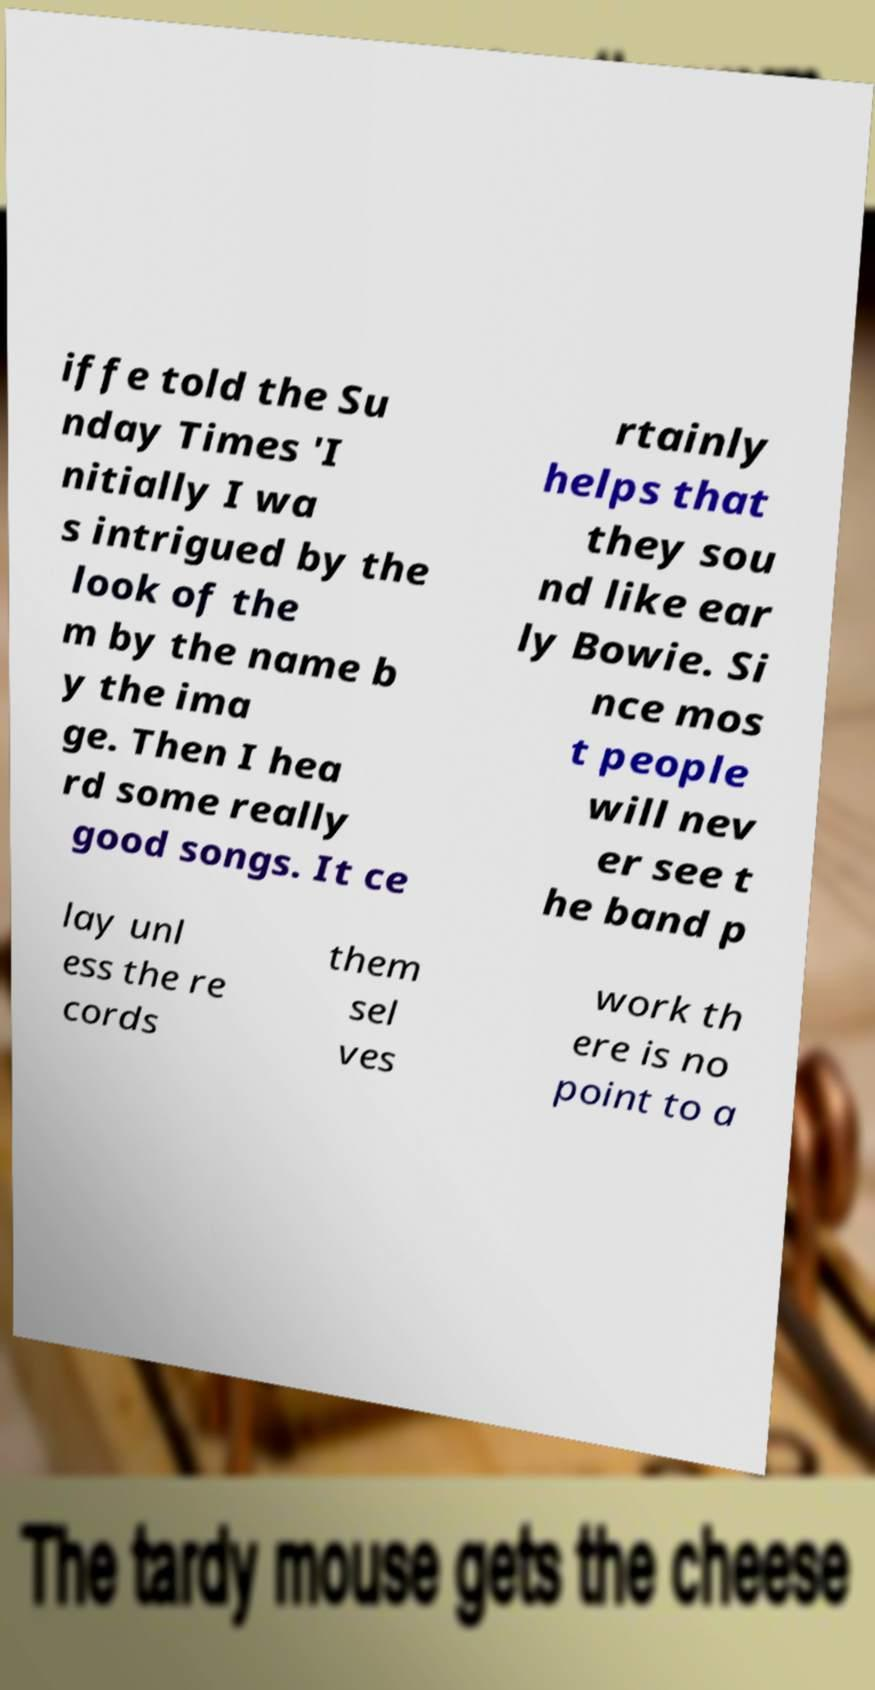I need the written content from this picture converted into text. Can you do that? iffe told the Su nday Times 'I nitially I wa s intrigued by the look of the m by the name b y the ima ge. Then I hea rd some really good songs. It ce rtainly helps that they sou nd like ear ly Bowie. Si nce mos t people will nev er see t he band p lay unl ess the re cords them sel ves work th ere is no point to a 